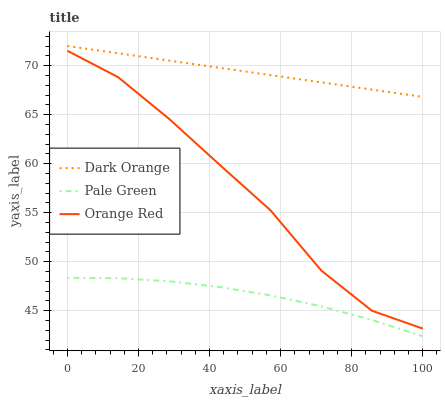Does Pale Green have the minimum area under the curve?
Answer yes or no. Yes. Does Dark Orange have the maximum area under the curve?
Answer yes or no. Yes. Does Orange Red have the minimum area under the curve?
Answer yes or no. No. Does Orange Red have the maximum area under the curve?
Answer yes or no. No. Is Dark Orange the smoothest?
Answer yes or no. Yes. Is Orange Red the roughest?
Answer yes or no. Yes. Is Pale Green the smoothest?
Answer yes or no. No. Is Pale Green the roughest?
Answer yes or no. No. Does Pale Green have the lowest value?
Answer yes or no. Yes. Does Orange Red have the lowest value?
Answer yes or no. No. Does Dark Orange have the highest value?
Answer yes or no. Yes. Does Orange Red have the highest value?
Answer yes or no. No. Is Orange Red less than Dark Orange?
Answer yes or no. Yes. Is Dark Orange greater than Pale Green?
Answer yes or no. Yes. Does Orange Red intersect Dark Orange?
Answer yes or no. No. 